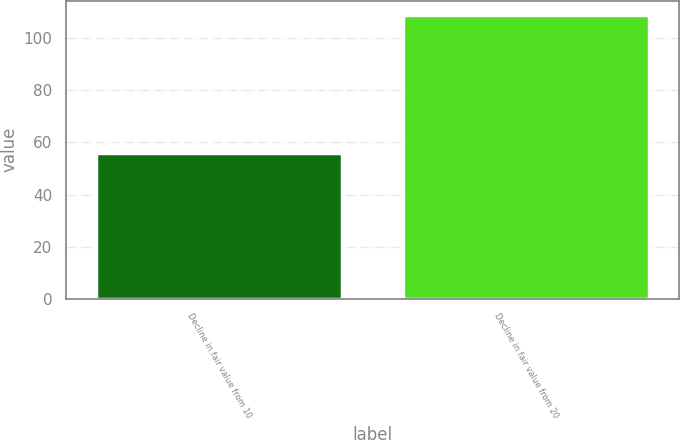Convert chart to OTSL. <chart><loc_0><loc_0><loc_500><loc_500><bar_chart><fcel>Decline in fair value from 10<fcel>Decline in fair value from 20<nl><fcel>56<fcel>109<nl></chart> 